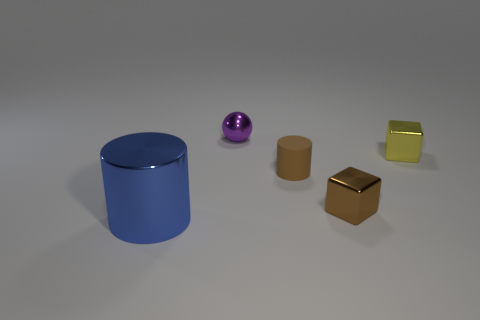How many metal objects are either small brown things or blue cubes?
Your answer should be very brief. 1. There is a small object that is in front of the cylinder to the right of the purple ball; what is it made of?
Make the answer very short. Metal. What is the material of the other tiny object that is the same color as the rubber thing?
Offer a very short reply. Metal. What color is the sphere?
Your answer should be very brief. Purple. There is a cylinder that is behind the brown block; are there any metal things that are behind it?
Offer a very short reply. Yes. What material is the small brown cylinder?
Your response must be concise. Rubber. Is the material of the tiny block behind the tiny rubber cylinder the same as the brown object on the right side of the tiny brown matte cylinder?
Ensure brevity in your answer.  Yes. Are there any other things that have the same color as the tiny cylinder?
Keep it short and to the point. Yes. There is another thing that is the same shape as the yellow shiny thing; what is its color?
Offer a terse response. Brown. What is the size of the metal thing that is both left of the brown metal cube and right of the blue metal object?
Your answer should be very brief. Small. 